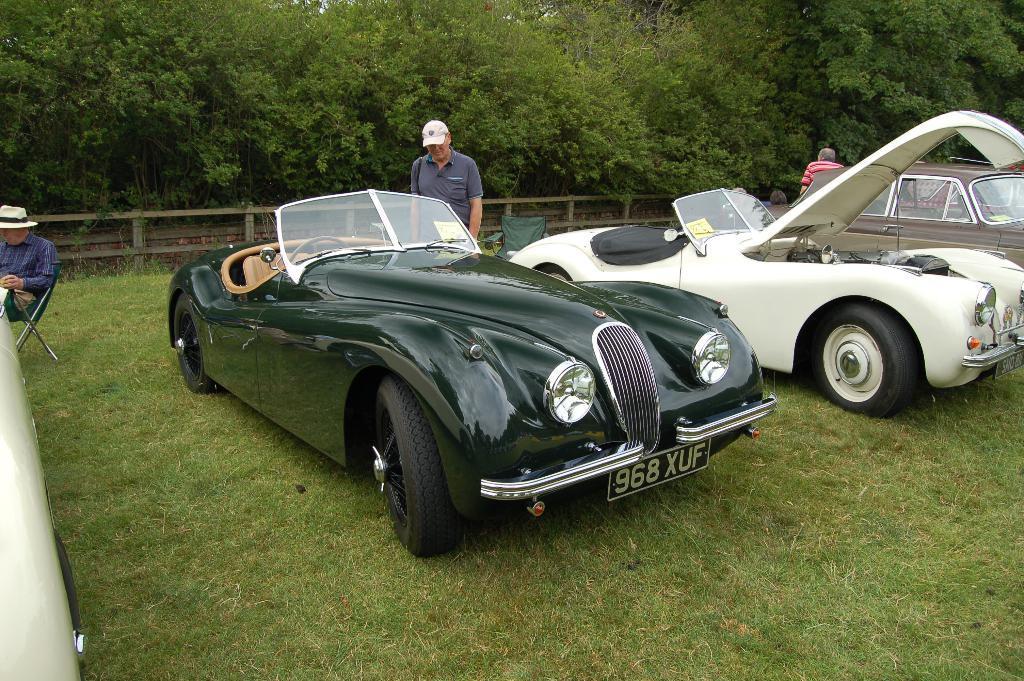Please provide a concise description of this image. In the image there are cars on the ground. On the ground there is grass. Behind the cars there are two men standing. On the left corner of the image there is a car. Behind the car there is a man with a hat is sitting on the chair. Behind them there is fencing. Behind the fencing there are trees. 